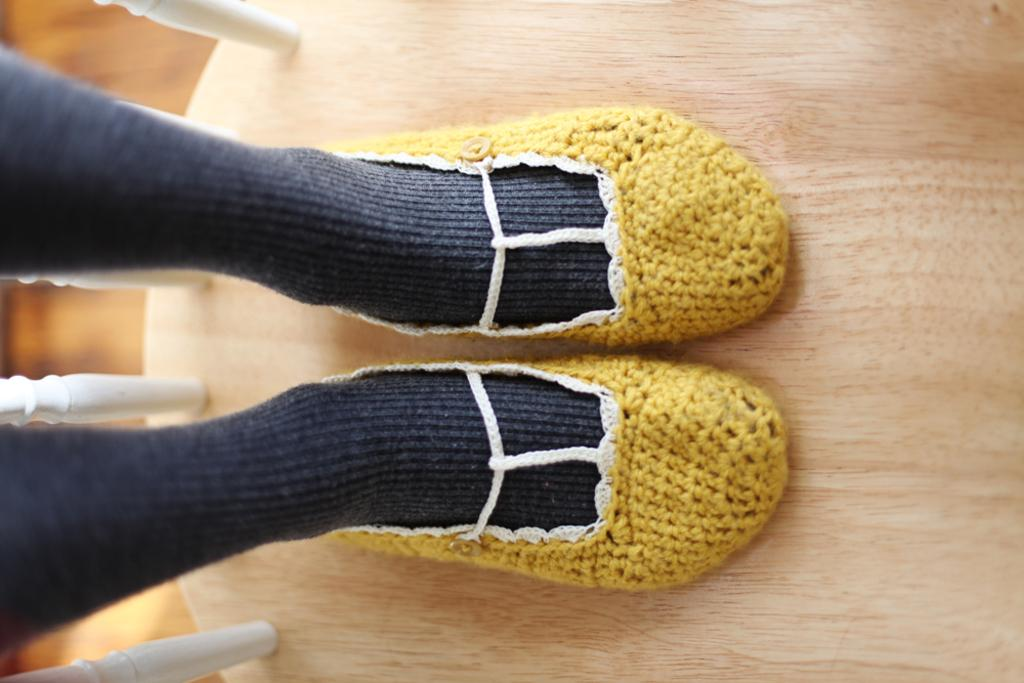What type of socks is the person in the image wearing? The person in the image is wearing black socks. What color are the shoes the person is wearing? The person is wearing yellow shoes. What material are the shoes made of? The shoes are made of wool. What type of flooring can be seen in the background of the image? There is a wooden floor in the background of the image. How many oranges are on the person's head in the image? There are no oranges present in the image. What is the person pointing at in the image? There is no indication in the image that the person is pointing at anything. 